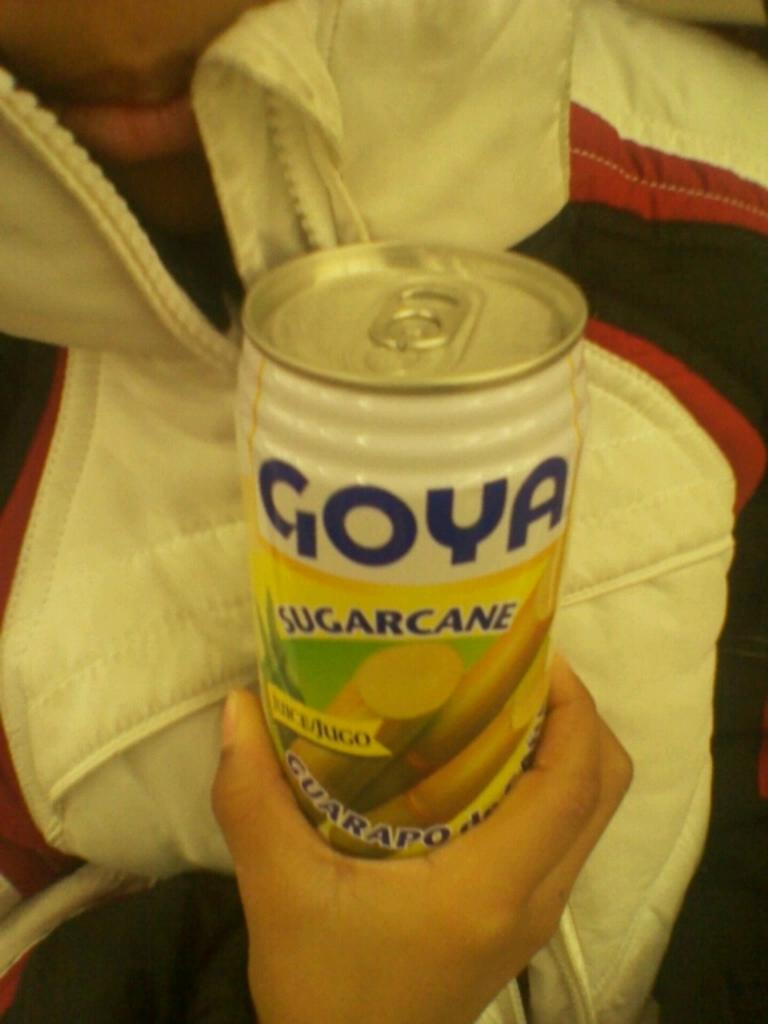What is present in the image? There is a person in the image. Can you describe the person's attire? The person is wearing a dress with red, black, and white colors. What is the person holding in the image? The person is holding a tin. How many mice are visible in the image? There are no mice present in the image. What type of hall can be seen in the background of the image? There is no hall visible in the image; it only features a person wearing a dress and holding a tin. 